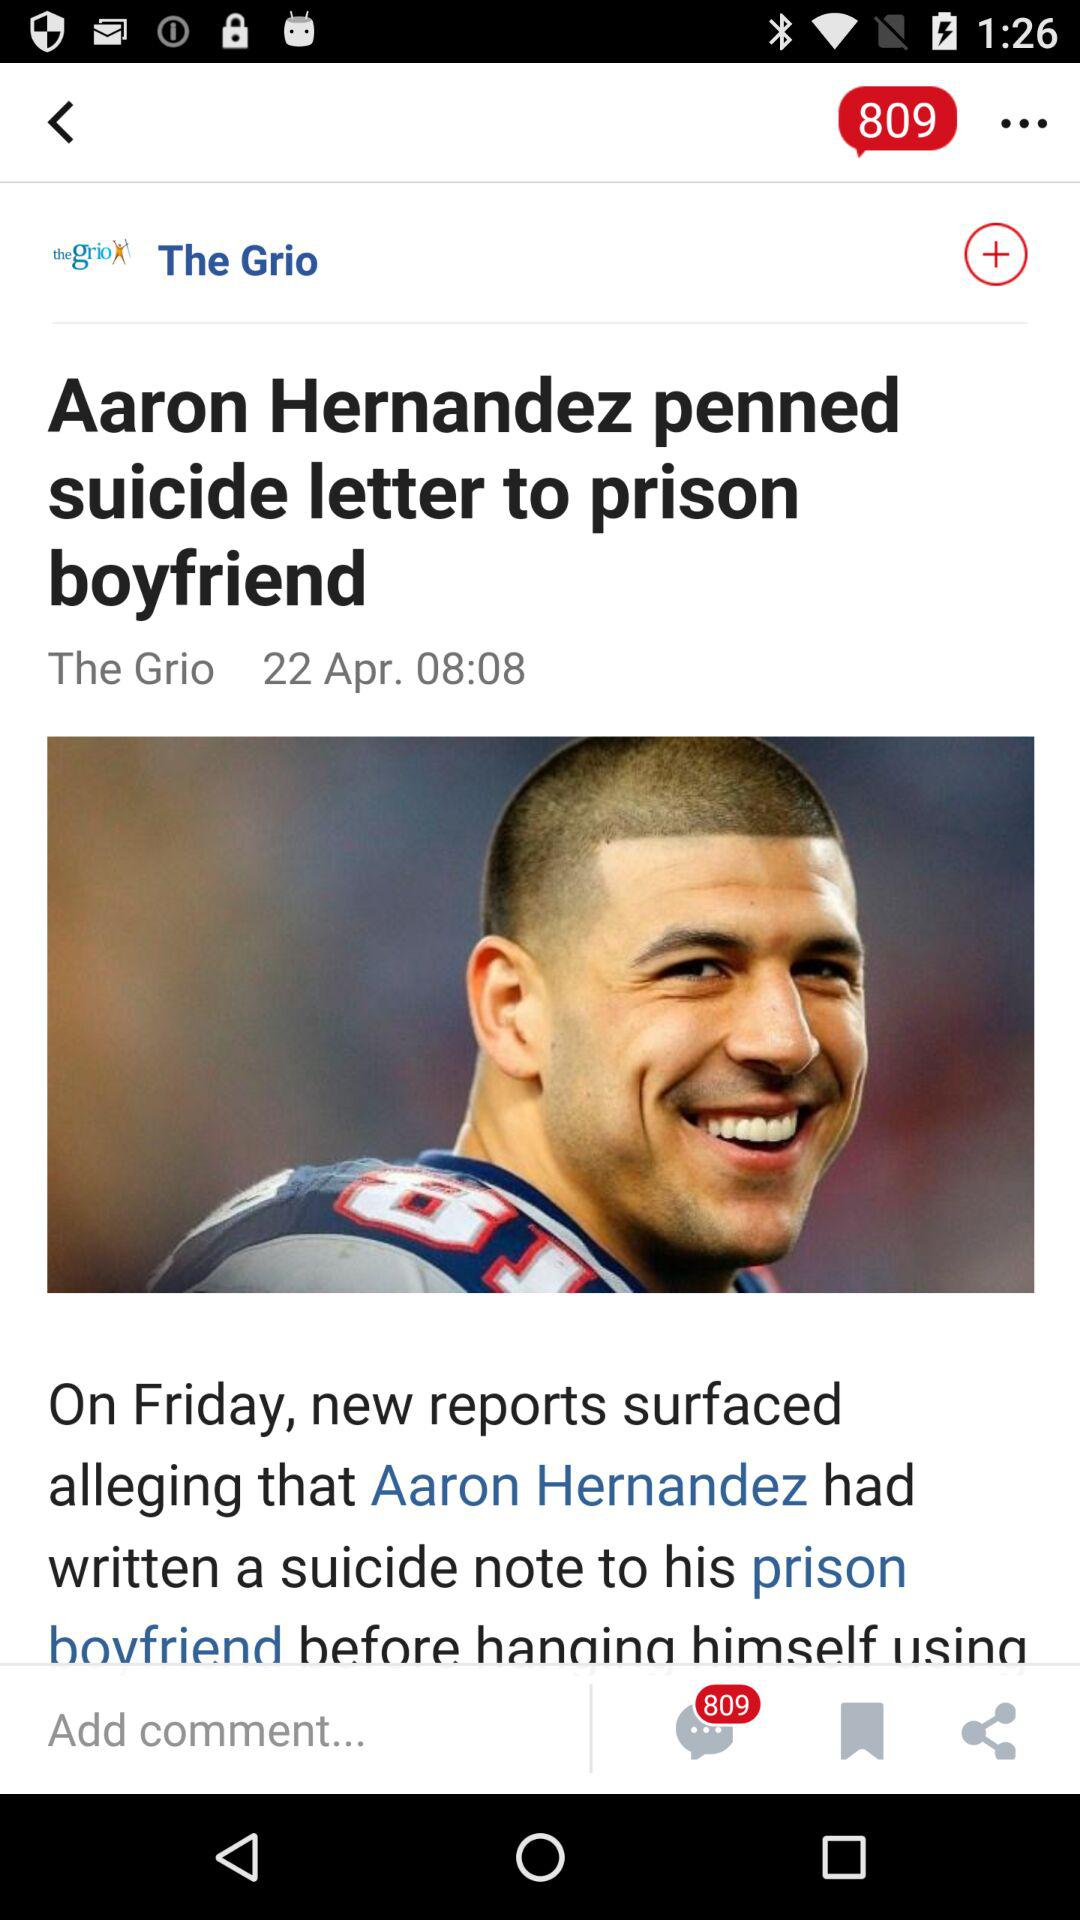How many unread comments are there? There are 809 unread comments. 